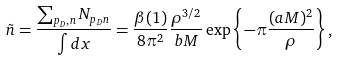<formula> <loc_0><loc_0><loc_500><loc_500>\tilde { n } = \frac { \sum _ { p _ { D } , n } N _ { p _ { D } n } } { \int d { x } } = \frac { \beta ( 1 ) } { 8 \pi ^ { 2 } } \frac { \rho ^ { 3 / 2 } } { b M } \exp \left \{ - \pi \frac { ( a M ) ^ { 2 } } { \rho } \right \} ,</formula> 